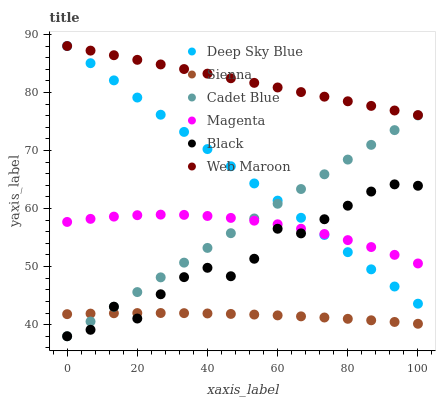Does Sienna have the minimum area under the curve?
Answer yes or no. Yes. Does Web Maroon have the maximum area under the curve?
Answer yes or no. Yes. Does Web Maroon have the minimum area under the curve?
Answer yes or no. No. Does Sienna have the maximum area under the curve?
Answer yes or no. No. Is Cadet Blue the smoothest?
Answer yes or no. Yes. Is Black the roughest?
Answer yes or no. Yes. Is Web Maroon the smoothest?
Answer yes or no. No. Is Web Maroon the roughest?
Answer yes or no. No. Does Cadet Blue have the lowest value?
Answer yes or no. Yes. Does Sienna have the lowest value?
Answer yes or no. No. Does Deep Sky Blue have the highest value?
Answer yes or no. Yes. Does Sienna have the highest value?
Answer yes or no. No. Is Black less than Web Maroon?
Answer yes or no. Yes. Is Web Maroon greater than Cadet Blue?
Answer yes or no. Yes. Does Magenta intersect Black?
Answer yes or no. Yes. Is Magenta less than Black?
Answer yes or no. No. Is Magenta greater than Black?
Answer yes or no. No. Does Black intersect Web Maroon?
Answer yes or no. No. 